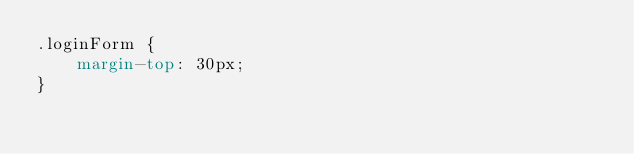Convert code to text. <code><loc_0><loc_0><loc_500><loc_500><_CSS_>.loginForm {
    margin-top: 30px;
}</code> 